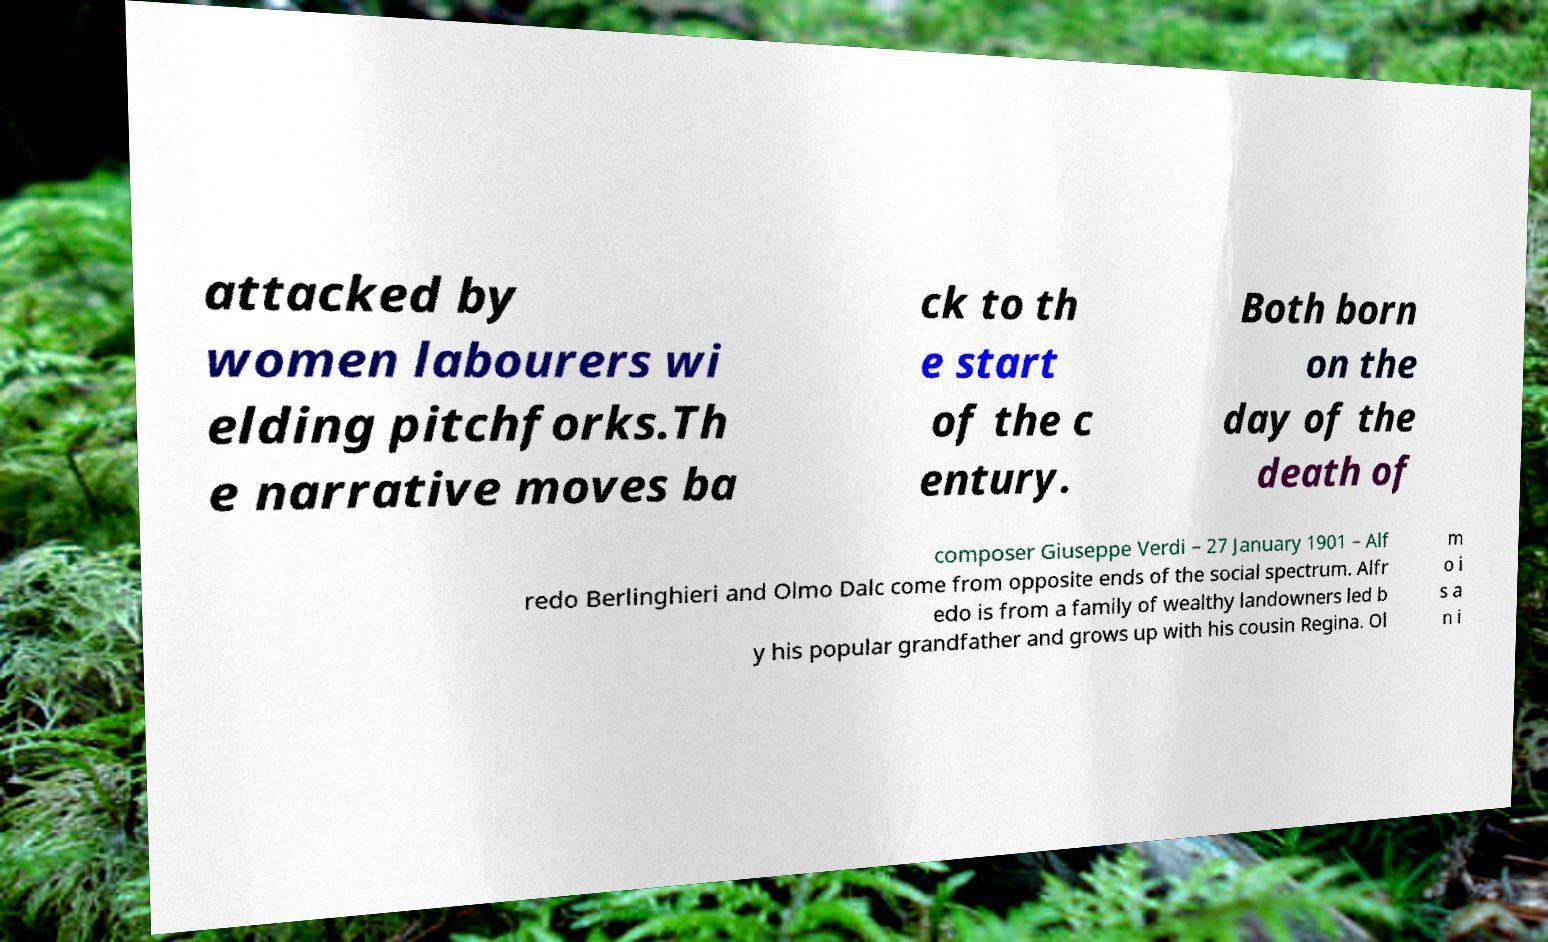Could you assist in decoding the text presented in this image and type it out clearly? attacked by women labourers wi elding pitchforks.Th e narrative moves ba ck to th e start of the c entury. Both born on the day of the death of composer Giuseppe Verdi – 27 January 1901 – Alf redo Berlinghieri and Olmo Dalc come from opposite ends of the social spectrum. Alfr edo is from a family of wealthy landowners led b y his popular grandfather and grows up with his cousin Regina. Ol m o i s a n i 